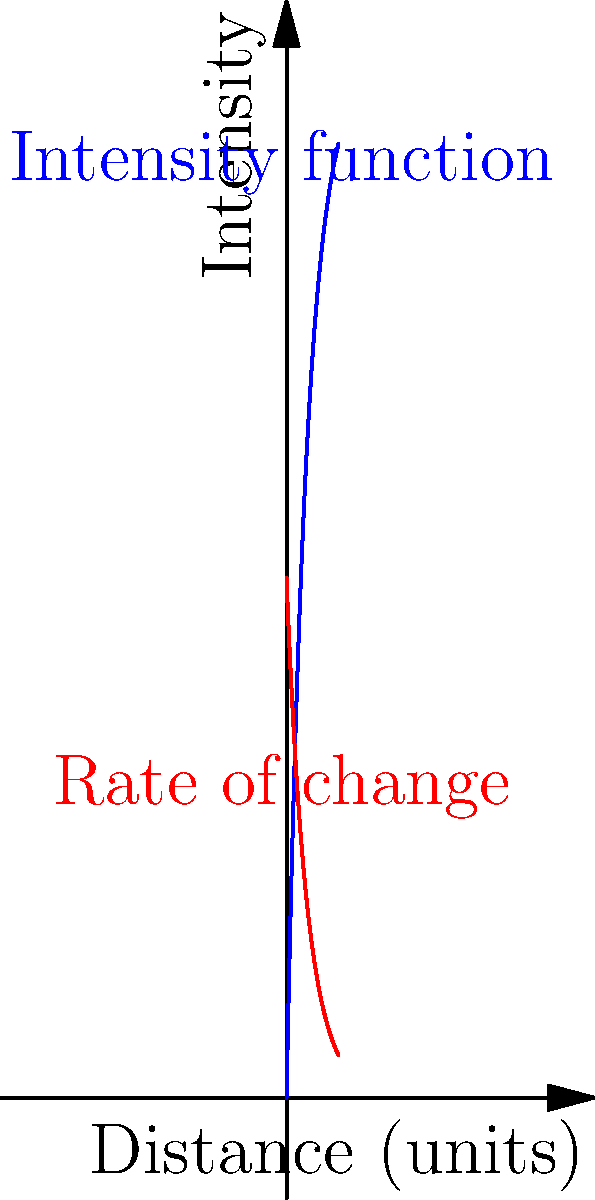In a virtual reality environment, the pixel intensity $I(x)$ across a gradient for realistic lighting effects is modeled by the function $I(x) = 100(1-e^{-0.5x})$, where $x$ is the distance from the light source in arbitrary units. At what distance from the light source is the rate of change of pixel intensity equal to 25 units per distance unit? To solve this problem, we need to follow these steps:

1) First, we need to find the rate of change of pixel intensity. This is given by the derivative of $I(x)$ with respect to $x$:

   $\frac{dI}{dx} = 100 \cdot 0.5e^{-0.5x} = 50e^{-0.5x}$

2) We want to find the value of $x$ where this rate of change equals 25:

   $50e^{-0.5x} = 25$

3) Divide both sides by 50:

   $e^{-0.5x} = 0.5$

4) Take the natural logarithm of both sides:

   $-0.5x = \ln(0.5)$

5) Divide both sides by -0.5:

   $x = -\frac{\ln(0.5)}{0.5} = \frac{\ln(2)}{0.5} \approx 1.386$

Therefore, the rate of change of pixel intensity is equal to 25 units per distance unit at approximately 1.386 units from the light source.
Answer: $\frac{\ln(2)}{0.5}$ units 